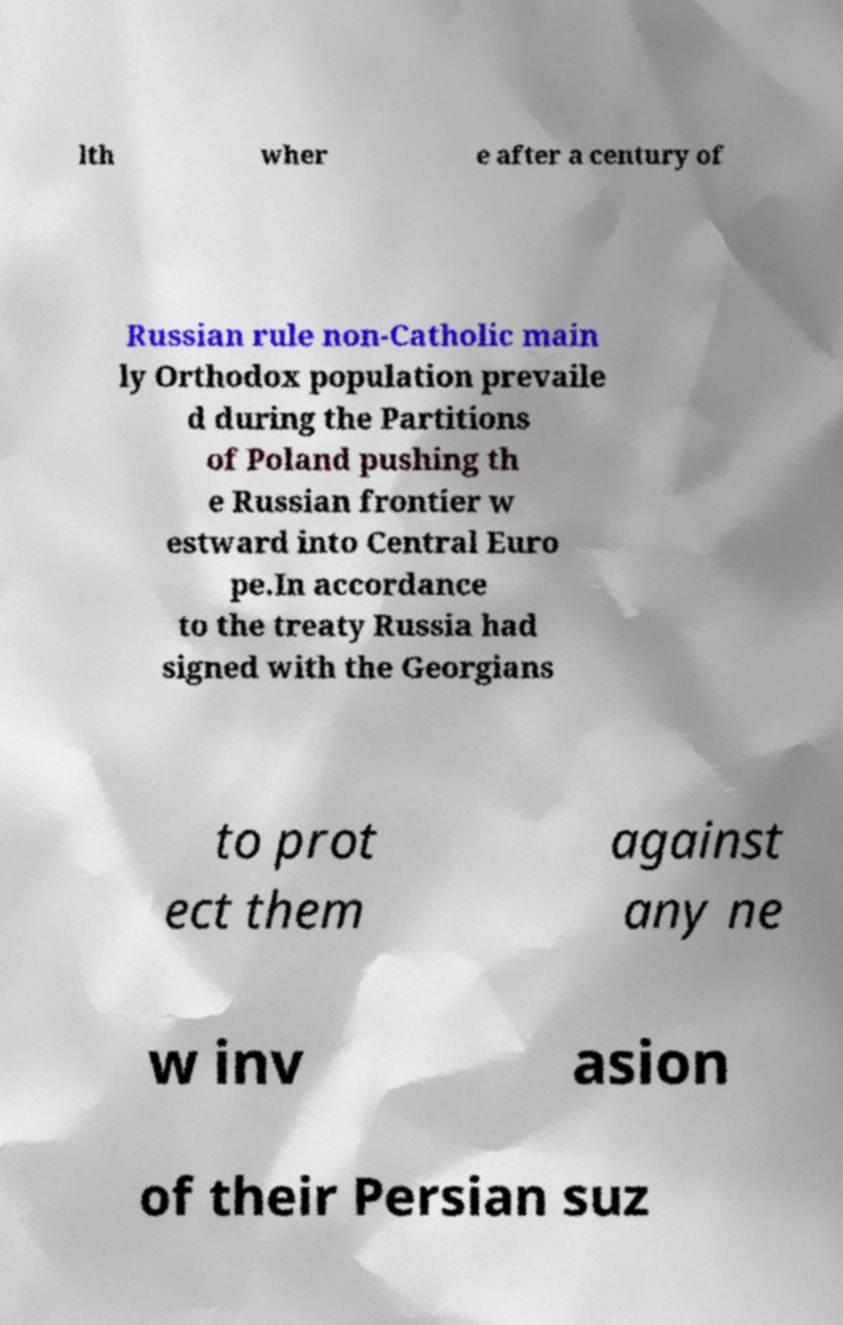I need the written content from this picture converted into text. Can you do that? lth wher e after a century of Russian rule non-Catholic main ly Orthodox population prevaile d during the Partitions of Poland pushing th e Russian frontier w estward into Central Euro pe.In accordance to the treaty Russia had signed with the Georgians to prot ect them against any ne w inv asion of their Persian suz 